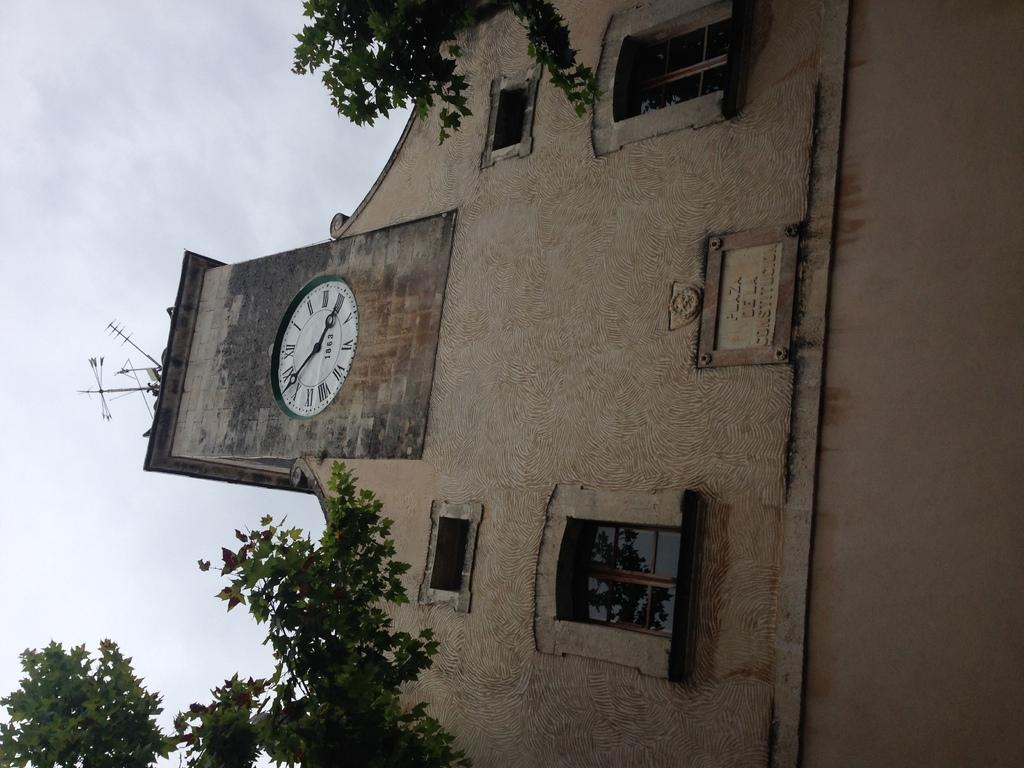<image>
Relay a brief, clear account of the picture shown. A lopsided picture of a clock tower has the date 1863 on the clock face. 